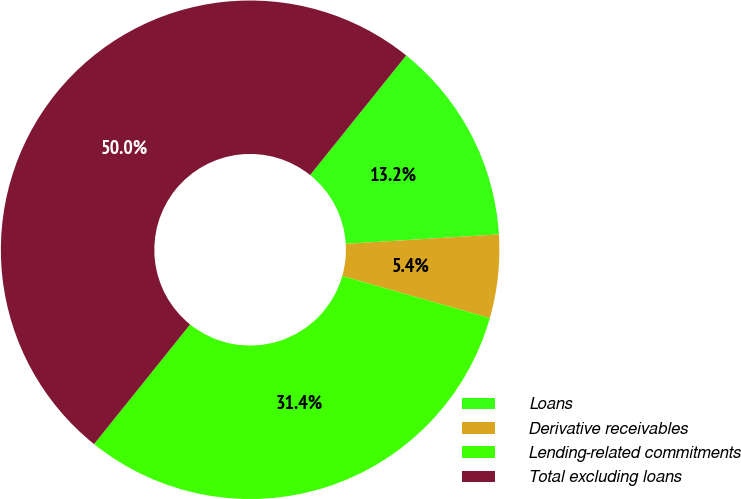<chart> <loc_0><loc_0><loc_500><loc_500><pie_chart><fcel>Loans<fcel>Derivative receivables<fcel>Lending-related commitments<fcel>Total excluding loans<nl><fcel>13.25%<fcel>5.4%<fcel>31.35%<fcel>50.0%<nl></chart> 